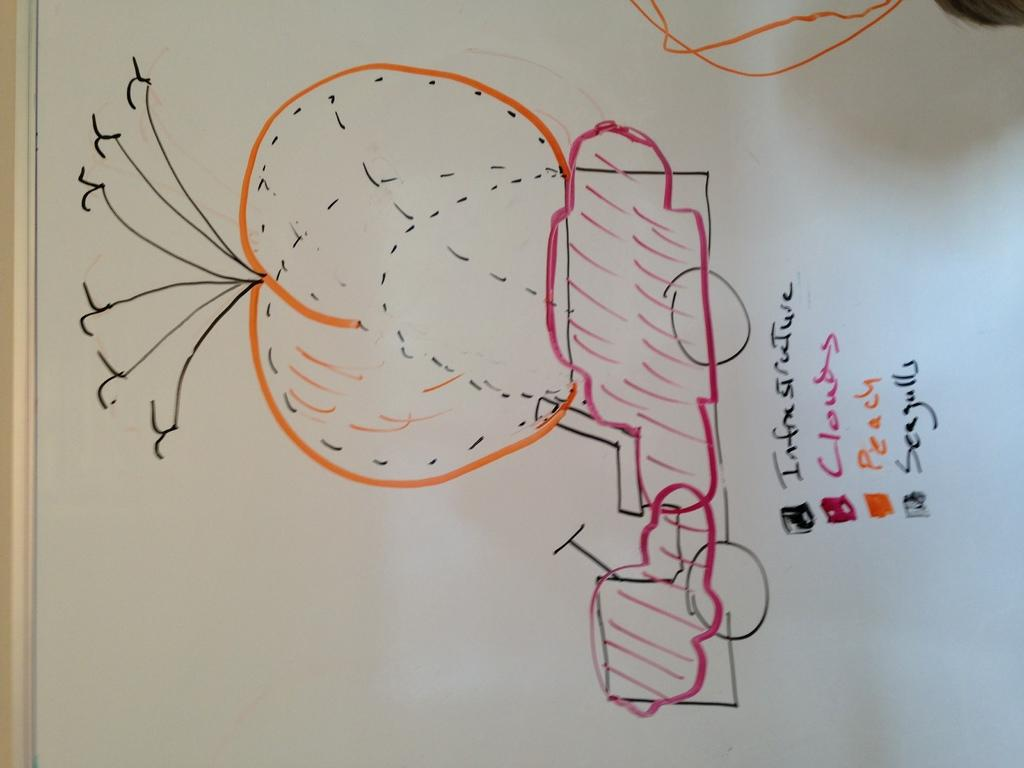Provide a one-sentence caption for the provided image. Different colors in a drawing signify things such as clouds and seagulls. 